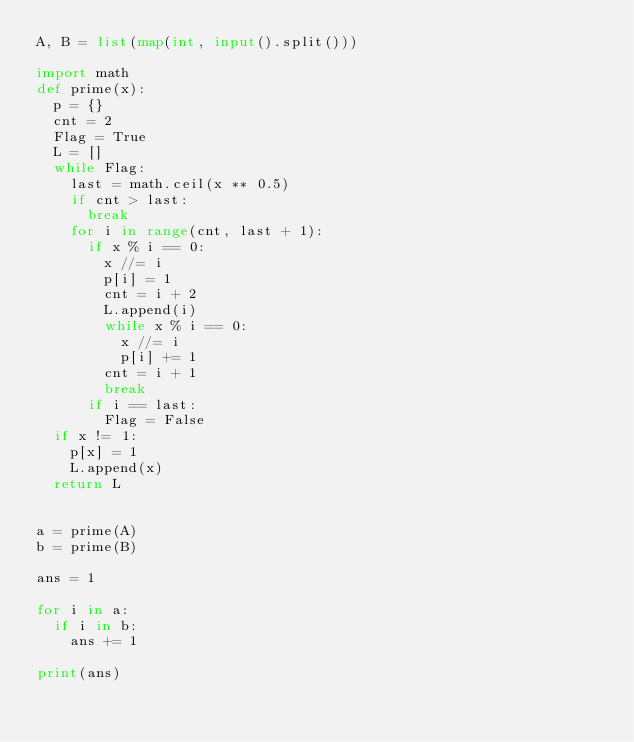Convert code to text. <code><loc_0><loc_0><loc_500><loc_500><_Python_>A, B = list(map(int, input().split()))

import math
def prime(x):
  p = {}
  cnt = 2
  Flag = True
  L = []
  while Flag:
    last = math.ceil(x ** 0.5) 
    if cnt > last:
      break
    for i in range(cnt, last + 1):
      if x % i == 0:
        x //= i
        p[i] = 1
        cnt = i + 2
        L.append(i)
        while x % i == 0:
          x //= i
          p[i] += 1
        cnt = i + 1
        break
      if i == last:
        Flag = False
  if x != 1:
    p[x] = 1
    L.append(x)
  return L


a = prime(A)
b = prime(B)

ans = 1

for i in a:
  if i in b:
    ans += 1

print(ans)</code> 